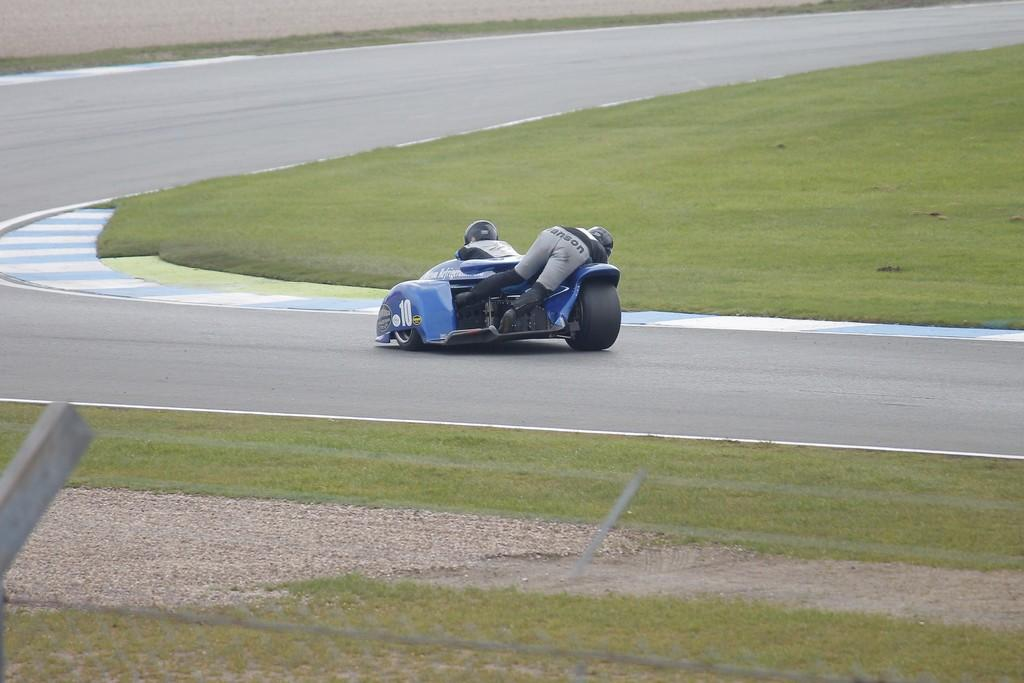What is the person doing in the image? The person is on a vehicle in the image. What type of surface is the vehicle on? The vehicle is on a road in the image. What type of vegetation can be seen in the image? There is grass visible in the image. Where is the tub located in the image? There is no tub present in the image. What type of footwear is the person wearing in the image? The provided facts do not mention the person's footwear, so we cannot determine if they are wearing boots or any other type of footwear. 